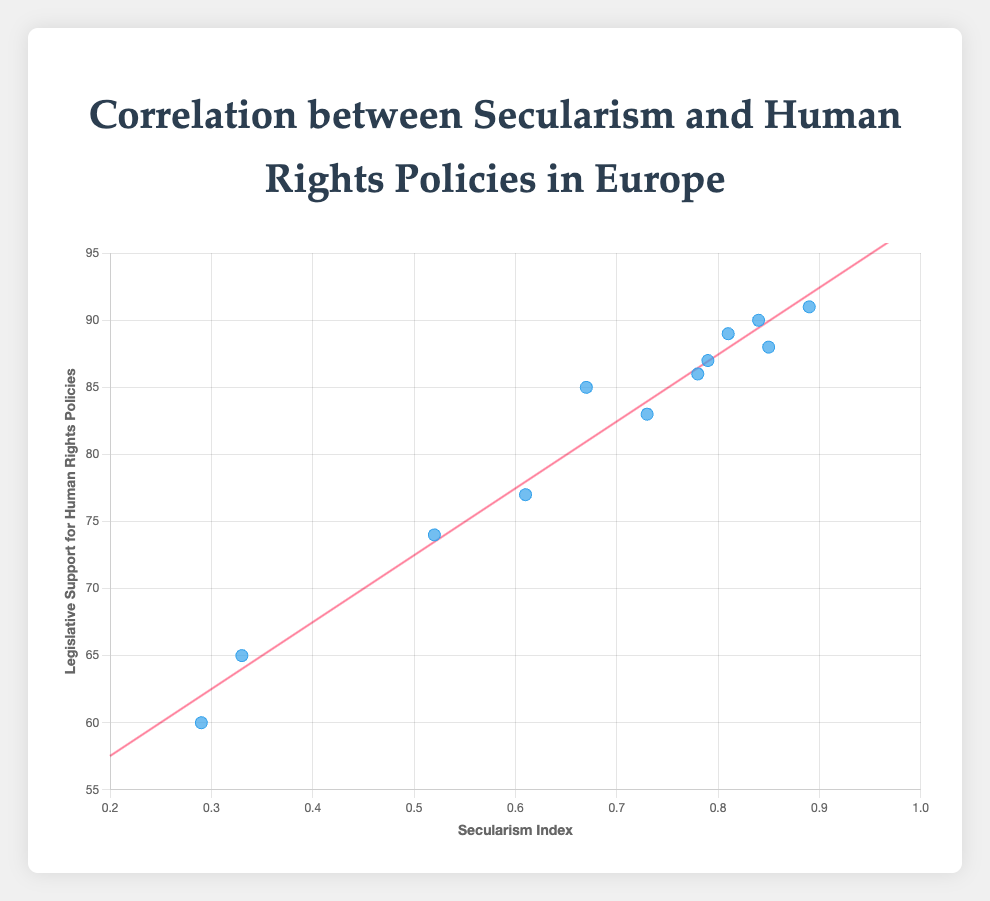What is the title of the scatter plot? The title of the scatter plot is prominently displayed at the top of the figure, and it describes the content being visualized.
Answer: Correlation between Secularism and Human Rights Policies in Europe What do the x and y axes represent in the scatter plot? The axes of the scatter plot are typically labeled to indicate what each dimension represents. The x-axis title is "Secularism Index," and the y-axis title is "Legislative Support for Human Rights Policies."
Answer: Secularism Index and Legislative Support for Human Rights Policies Which country has the highest secularism index? By examining the data points along the x-axis, we can find the one that is farthest to the right, indicating the highest secularism index value.
Answer: Sweden Which country has the lowest legislative support for human rights policies? By looking at the data points along the y-axis, we find the one that is positioned lowest, indicating the minimum value for legislative support for human rights.
Answer: Hungary What is the overall trend shown by the scatter plot's trend line? The trend line in the scatter plot provides a visual summary of the relationship between secularism index and legislative support for human rights. By examining the slope, we can determine the overall trend.
Answer: Positive correlation Which two countries have the closest values for both secularism index and legislative support for human rights policies? To answer this, we need to find the pair of data points that are closest to each other in both the x and y dimensions. The scatter plot's arrangement makes this task manageable.
Answer: Belgium and Netherlands Are there any outliers in the scatter plot, and if so, which countries are they? Outliers are data points that deviate markedly from the pattern formed by the other points. By examining the scatter plot, we can identify any such points.
Answer: Hungary (low values), Sweden (high secularism index) Which country has a secularism index closest to 0.8 and what is its legislative support for human rights policies? We look for the data point where the x-value is nearest to 0.8 on the scatter plot and then identify its corresponding y-value.
Answer: Denmark (89) What is the approximate range of the secularism index values in this dataset? We need to find the minimum and maximum x-values in the scatter plot to determine the range of the secularism index values. The minimum is around 0.29 (Hungary) and the maximum is 0.89 (Sweden).
Answer: 0.29 to 0.89 Is there a country with high legislative support for human rights policies but a relatively low secularism index? We are looking for a data point that is positioned high on the y-axis but relatively low on the x-axis compared to others. This indicates high legislative support but lower secularism index.
Answer: Germany (support: 85, index: 0.67) 